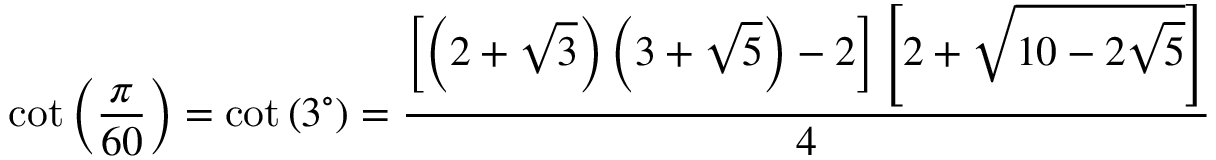<formula> <loc_0><loc_0><loc_500><loc_500>\cot \left ( { \frac { \pi } { 6 0 } } \right ) = \cot \left ( 3 ^ { \circ } \right ) = { \frac { \left [ \left ( 2 + { \sqrt { 3 } } \right ) \left ( 3 + { \sqrt { 5 } } \right ) - 2 \right ] \left [ 2 + { \sqrt { 1 0 - 2 { \sqrt { 5 } } } } \right ] } { 4 } }</formula> 